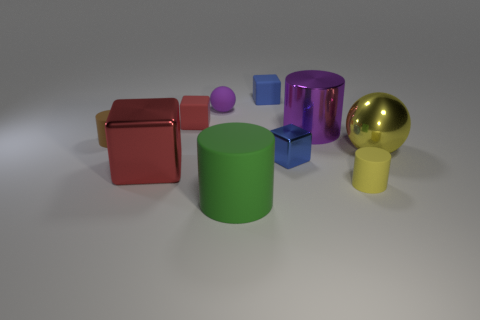Do the objects share a common material or are they varied? The objects are varied in materials; some appear metallic like the gold and purple objects, while others look matte, such as the red and green ones. Could you guess the purpose of the scene in the image? It seems like a demonstration of 3D modeling, showcasing different shapes and materials. 